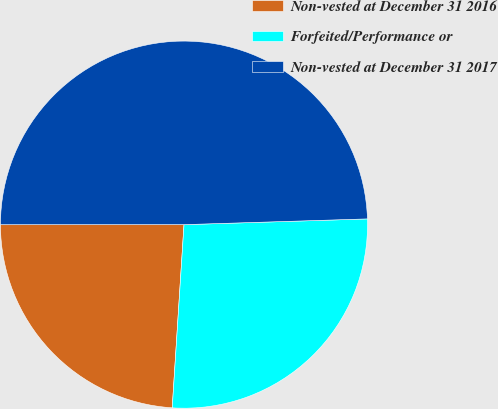Convert chart. <chart><loc_0><loc_0><loc_500><loc_500><pie_chart><fcel>Non-vested at December 31 2016<fcel>Forfeited/Performance or<fcel>Non-vested at December 31 2017<nl><fcel>23.97%<fcel>26.52%<fcel>49.51%<nl></chart> 